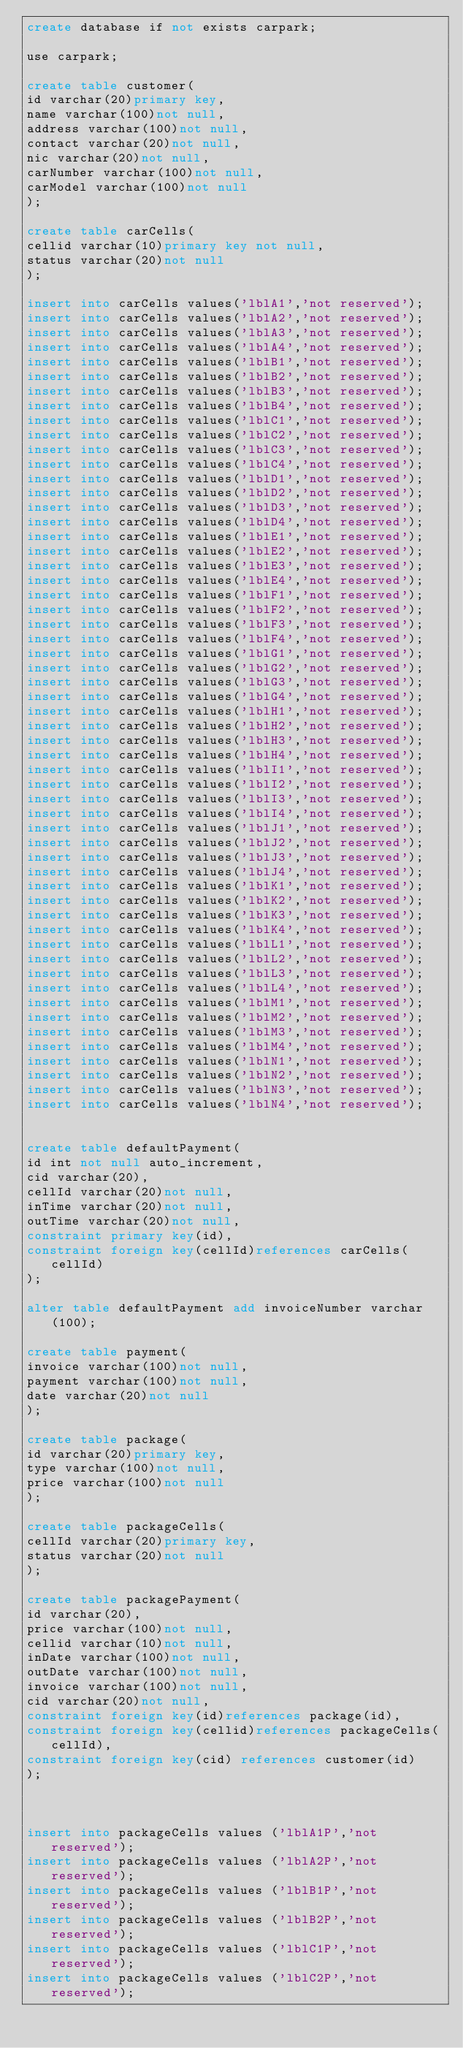Convert code to text. <code><loc_0><loc_0><loc_500><loc_500><_SQL_>create database if not exists carpark;

use carpark;

create table customer(
id varchar(20)primary key,
name varchar(100)not null,
address varchar(100)not null,
contact varchar(20)not null,
nic varchar(20)not null,
carNumber varchar(100)not null,
carModel varchar(100)not null
);

create table carCells(
cellid varchar(10)primary key not null,
status varchar(20)not null
);

insert into carCells values('lblA1','not reserved');
insert into carCells values('lblA2','not reserved');
insert into carCells values('lblA3','not reserved');
insert into carCells values('lblA4','not reserved');
insert into carCells values('lblB1','not reserved');
insert into carCells values('lblB2','not reserved');
insert into carCells values('lblB3','not reserved');
insert into carCells values('lblB4','not reserved');
insert into carCells values('lblC1','not reserved');
insert into carCells values('lblC2','not reserved');
insert into carCells values('lblC3','not reserved');
insert into carCells values('lblC4','not reserved');
insert into carCells values('lblD1','not reserved');
insert into carCells values('lblD2','not reserved');
insert into carCells values('lblD3','not reserved');
insert into carCells values('lblD4','not reserved');
insert into carCells values('lblE1','not reserved');
insert into carCells values('lblE2','not reserved');
insert into carCells values('lblE3','not reserved');
insert into carCells values('lblE4','not reserved');
insert into carCells values('lblF1','not reserved');
insert into carCells values('lblF2','not reserved');
insert into carCells values('lblF3','not reserved');
insert into carCells values('lblF4','not reserved');
insert into carCells values('lblG1','not reserved');
insert into carCells values('lblG2','not reserved');
insert into carCells values('lblG3','not reserved');
insert into carCells values('lblG4','not reserved');
insert into carCells values('lblH1','not reserved');
insert into carCells values('lblH2','not reserved');
insert into carCells values('lblH3','not reserved');
insert into carCells values('lblH4','not reserved');
insert into carCells values('lblI1','not reserved');
insert into carCells values('lblI2','not reserved');
insert into carCells values('lblI3','not reserved');
insert into carCells values('lblI4','not reserved');
insert into carCells values('lblJ1','not reserved');
insert into carCells values('lblJ2','not reserved');
insert into carCells values('lblJ3','not reserved');
insert into carCells values('lblJ4','not reserved');
insert into carCells values('lblK1','not reserved');
insert into carCells values('lblK2','not reserved');
insert into carCells values('lblK3','not reserved');
insert into carCells values('lblK4','not reserved');
insert into carCells values('lblL1','not reserved');
insert into carCells values('lblL2','not reserved');
insert into carCells values('lblL3','not reserved');
insert into carCells values('lblL4','not reserved');
insert into carCells values('lblM1','not reserved');
insert into carCells values('lblM2','not reserved');
insert into carCells values('lblM3','not reserved');
insert into carCells values('lblM4','not reserved');
insert into carCells values('lblN1','not reserved');
insert into carCells values('lblN2','not reserved');
insert into carCells values('lblN3','not reserved');
insert into carCells values('lblN4','not reserved');


create table defaultPayment(
id int not null auto_increment,
cid varchar(20),
cellId varchar(20)not null,
inTime varchar(20)not null,
outTime varchar(20)not null,
constraint primary key(id),
constraint foreign key(cellId)references carCells(cellId)
);

alter table defaultPayment add invoiceNumber varchar(100);

create table payment(
invoice varchar(100)not null,
payment varchar(100)not null,
date varchar(20)not null
);

create table package(
id varchar(20)primary key,
type varchar(100)not null,
price varchar(100)not null
);

create table packageCells(
cellId varchar(20)primary key,
status varchar(20)not null
);

create table packagePayment(
id varchar(20),
price varchar(100)not null,
cellid varchar(10)not null,
inDate varchar(100)not null,
outDate varchar(100)not null,
invoice varchar(100)not null,
cid varchar(20)not null,
constraint foreign key(id)references package(id),
constraint foreign key(cellid)references packageCells(cellId),
constraint foreign key(cid) references customer(id)
);



insert into packageCells values ('lblA1P','not reserved');
insert into packageCells values ('lblA2P','not reserved');
insert into packageCells values ('lblB1P','not reserved');
insert into packageCells values ('lblB2P','not reserved');
insert into packageCells values ('lblC1P','not reserved');
insert into packageCells values ('lblC2P','not reserved');</code> 